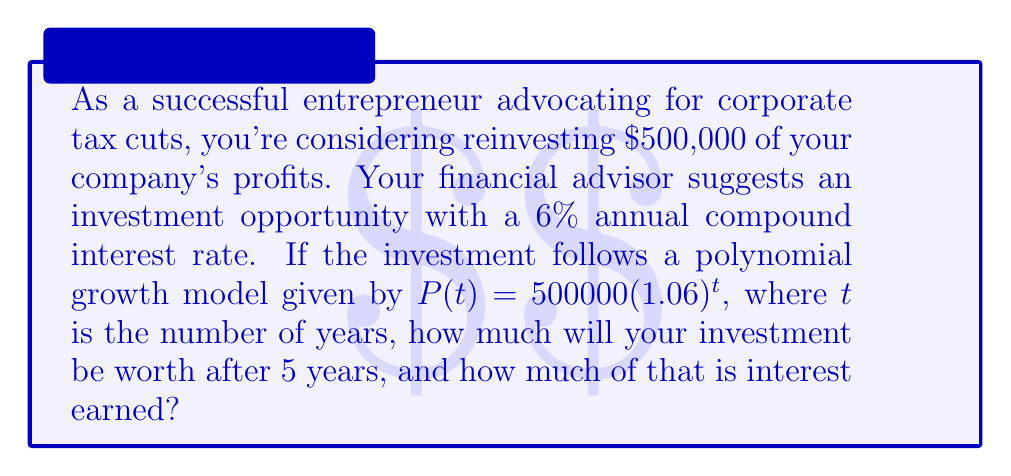Could you help me with this problem? Let's approach this step-by-step:

1) The polynomial function for compound interest is given as:
   $P(t) = 500000(1.06)^t$

2) We need to calculate the value after 5 years, so we substitute $t = 5$:
   $P(5) = 500000(1.06)^5$

3) Let's calculate this:
   $P(5) = 500000 \times 1.33823069$
   $P(5) = 669115.34$

4) So, after 5 years, the investment will be worth $669,115.34.

5) To find the interest earned, we subtract the initial investment:
   Interest = Final Value - Initial Investment
   Interest = $669115.34 - $500000 = $169115.34

Therefore, the investment will be worth $669,115.34 after 5 years, and $169,115.34 of that is interest earned.
Answer: $669,115.34 total; $169,115.34 interest 